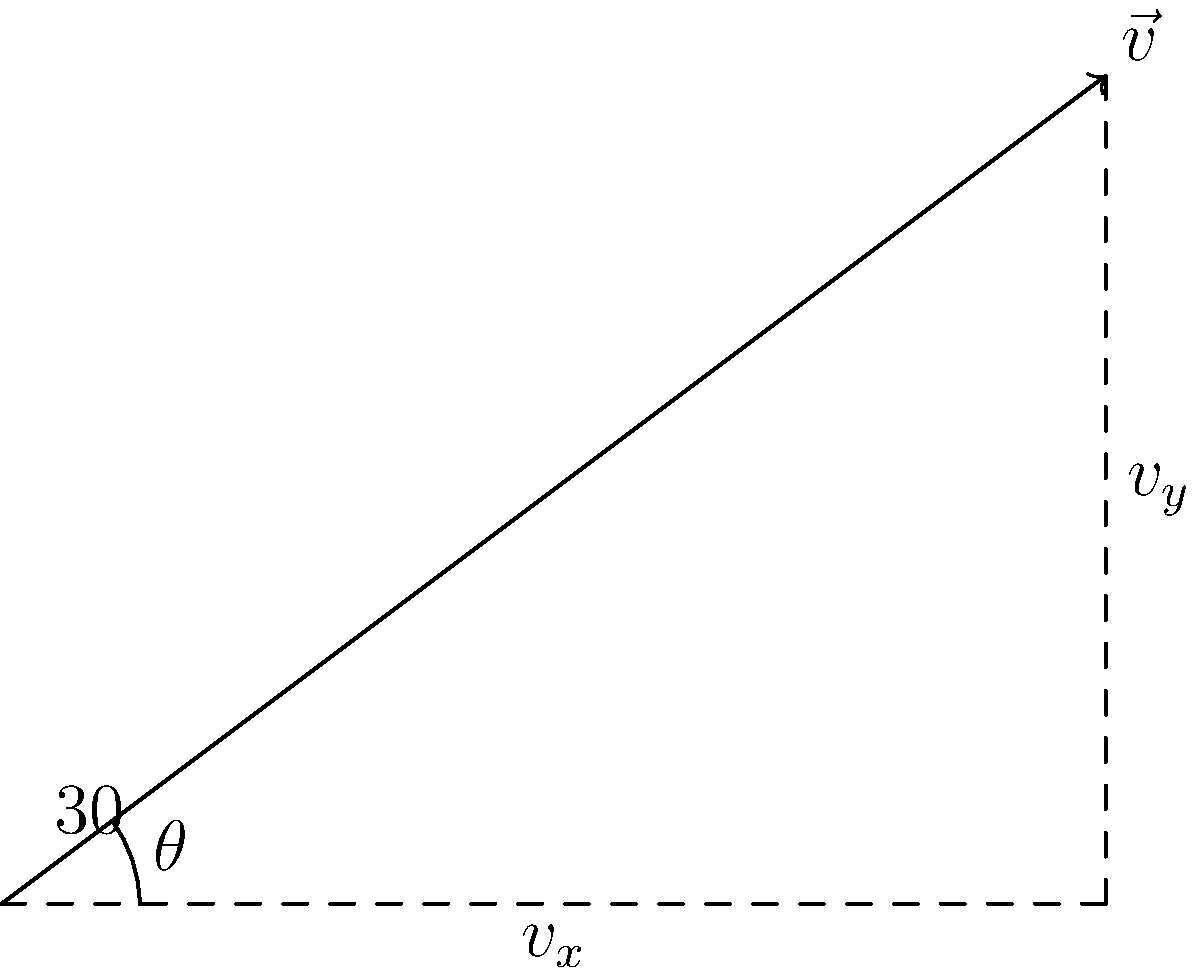A landslide is moving down a slope with a velocity of 20 m/s at an angle of 30° below the horizontal. Calculate the horizontal and vertical components of the velocity vector. To solve this problem, we need to decompose the velocity vector into its horizontal and vertical components using trigonometric functions. Let's follow these steps:

1) Given:
   - Total velocity, $v = 20$ m/s
   - Angle below horizontal, $\theta = 30°$

2) For the horizontal component ($v_x$):
   $v_x = v \cos(\theta)$
   $v_x = 20 \cos(30°)$
   $v_x = 20 \cdot \frac{\sqrt{3}}{2} \approx 17.32$ m/s

3) For the vertical component ($v_y$):
   $v_y = v \sin(\theta)$
   $v_y = 20 \sin(30°)$
   $v_y = 20 \cdot \frac{1}{2} = 10$ m/s

4) Note that the vertical component is negative in this case because the landslide is moving downwards.

Therefore, the horizontal component is approximately 17.32 m/s to the right, and the vertical component is 10 m/s downward.
Answer: $v_x \approx 17.32$ m/s right, $v_y = 10$ m/s down 